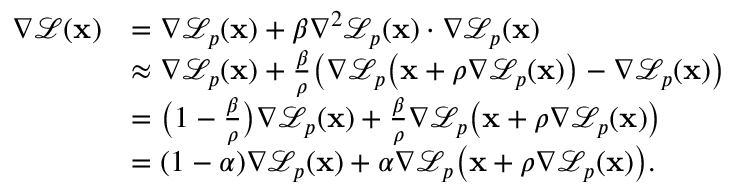Convert formula to latex. <formula><loc_0><loc_0><loc_500><loc_500>\begin{array} { r l } { \nabla \mathcal { L } ( x ) } & { = \nabla \mathcal { L } _ { p } ( x ) + \beta \nabla ^ { 2 } \mathcal { L } _ { p } ( x ) \cdot \nabla \mathcal { L } _ { p } ( x ) } \\ & { \approx \nabla \mathcal { L } _ { p } ( x ) + \frac { \beta } { \rho } \left ( \nabla \mathcal { L } _ { p } \left ( x + \rho \nabla \mathcal { L } _ { p } ( x ) \right ) - \nabla \mathcal { L } _ { p } ( x ) \right ) } \\ & { = \left ( 1 - \frac { \beta } { \rho } \right ) \nabla \mathcal { L } _ { p } ( x ) + \frac { \beta } { \rho } \nabla \mathcal { L } _ { p } \left ( x + \rho \nabla \mathcal { L } _ { p } ( x ) \right ) } \\ & { = ( 1 - \alpha ) \nabla \mathcal { L } _ { p } ( x ) + \alpha \nabla \mathcal { L } _ { p } \left ( x + \rho \nabla \mathcal { L } _ { p } ( x ) \right ) . } \end{array}</formula> 